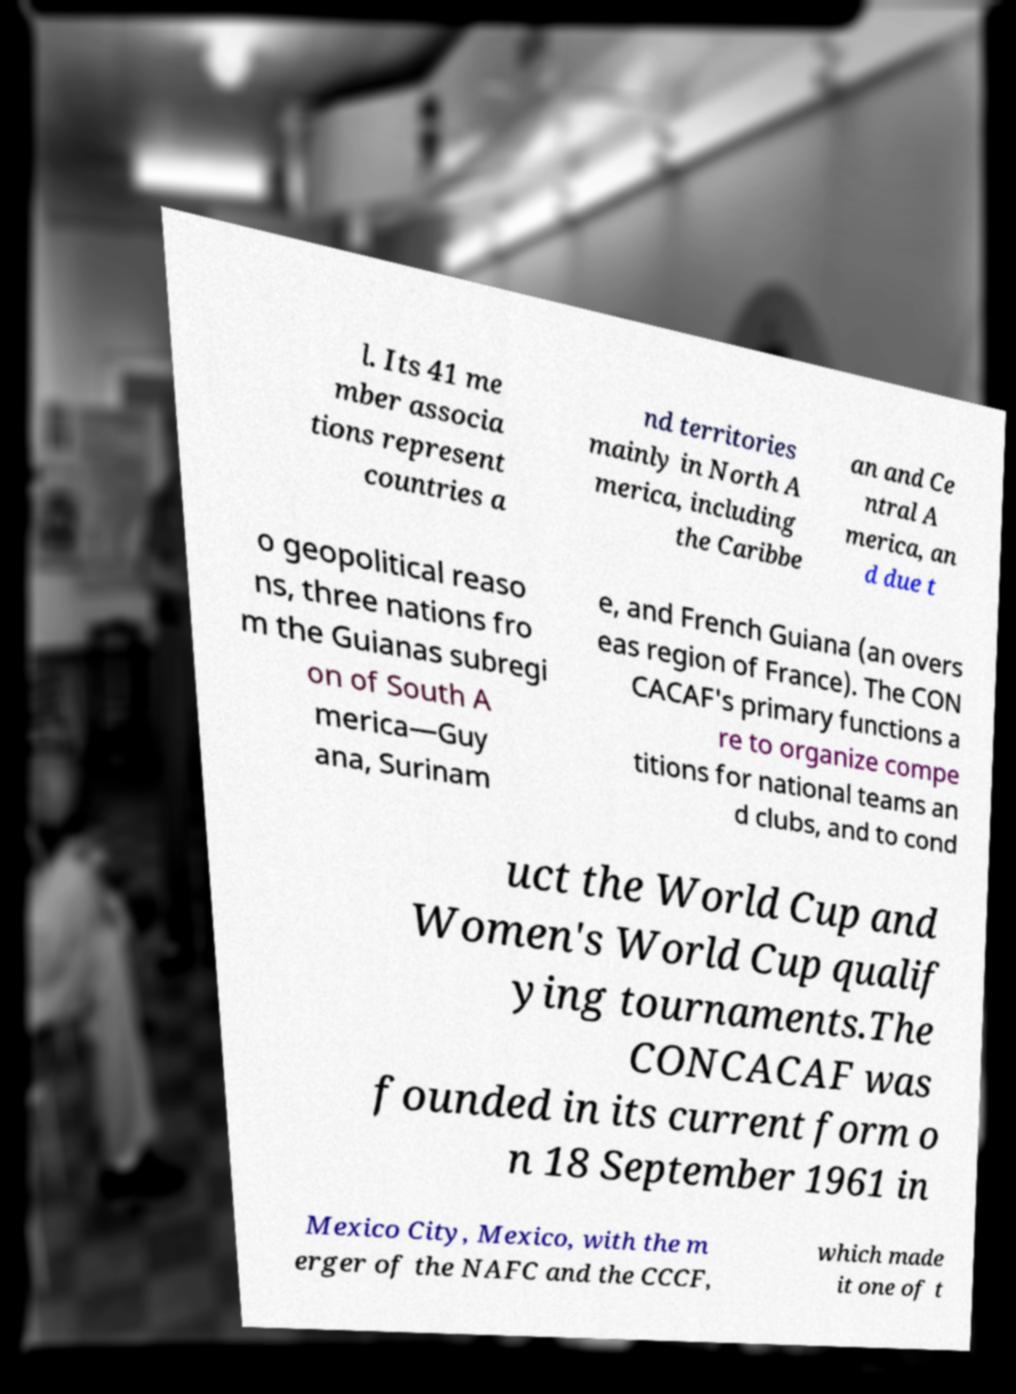I need the written content from this picture converted into text. Can you do that? l. Its 41 me mber associa tions represent countries a nd territories mainly in North A merica, including the Caribbe an and Ce ntral A merica, an d due t o geopolitical reaso ns, three nations fro m the Guianas subregi on of South A merica—Guy ana, Surinam e, and French Guiana (an overs eas region of France). The CON CACAF's primary functions a re to organize compe titions for national teams an d clubs, and to cond uct the World Cup and Women's World Cup qualif ying tournaments.The CONCACAF was founded in its current form o n 18 September 1961 in Mexico City, Mexico, with the m erger of the NAFC and the CCCF, which made it one of t 